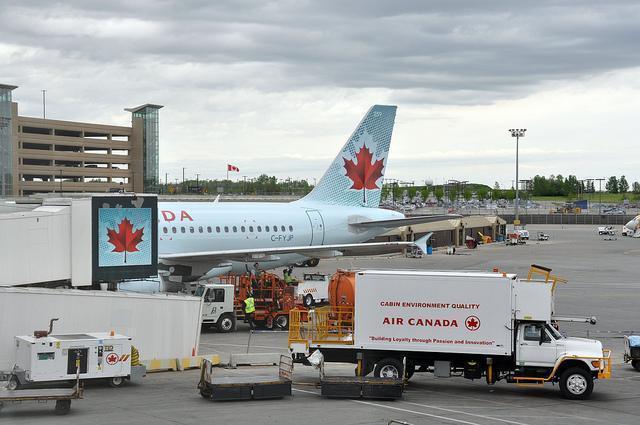What continent is this country located at?
Answer the question by selecting the correct answer among the 4 following choices.
Options: North america, asia, south america, australia. North america. 